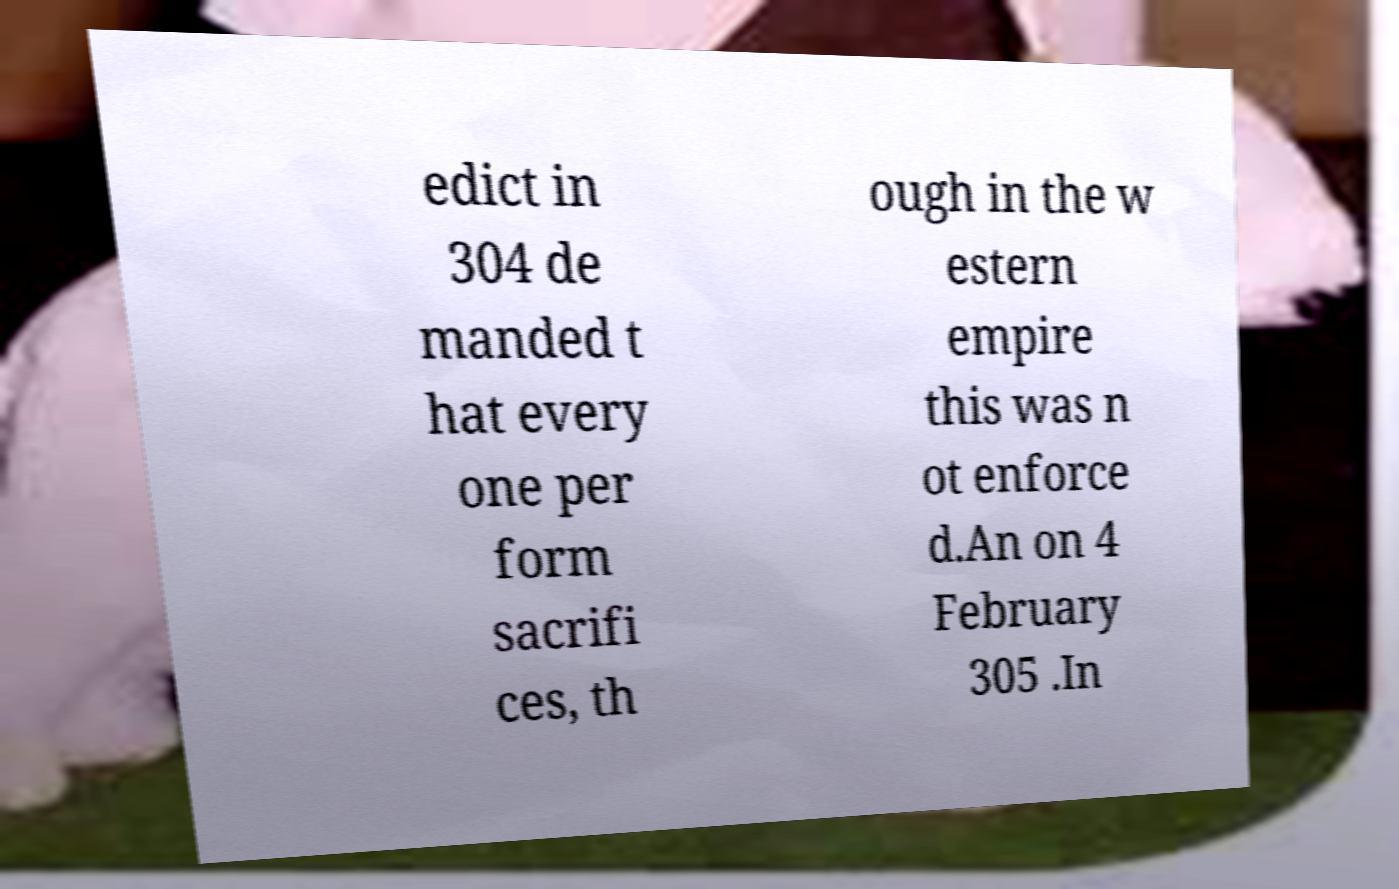Can you read and provide the text displayed in the image?This photo seems to have some interesting text. Can you extract and type it out for me? edict in 304 de manded t hat every one per form sacrifi ces, th ough in the w estern empire this was n ot enforce d.An on 4 February 305 .In 